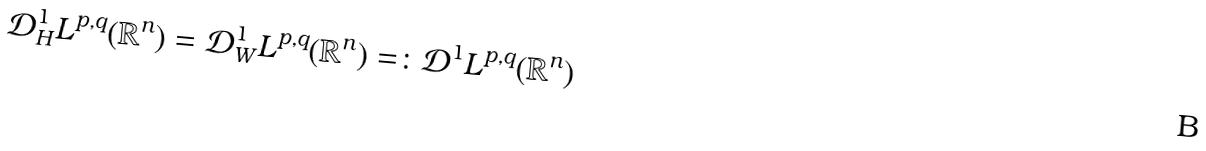Convert formula to latex. <formula><loc_0><loc_0><loc_500><loc_500>\mathcal { D } _ { H } ^ { 1 } L ^ { p , q } ( \mathbb { R } ^ { n } ) = \mathcal { D } _ { W } ^ { 1 } L ^ { p , q } ( \mathbb { R } ^ { n } ) = \colon \mathcal { D } ^ { 1 } L ^ { p , q } ( \mathbb { R } ^ { n } )</formula> 